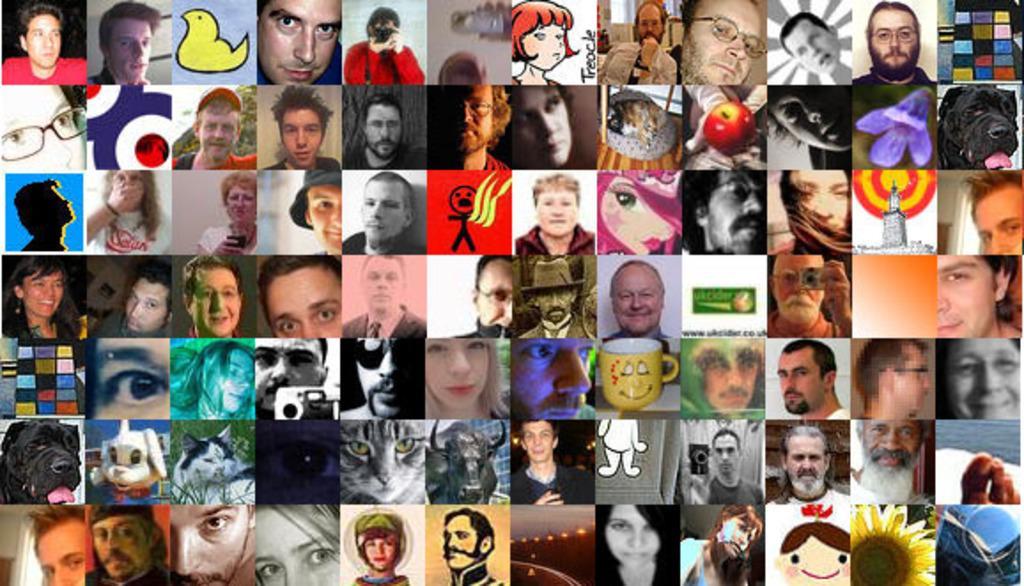Can you describe this image briefly? In the picture I can see the collage images. I can see the face of persons, images of animals, flowers and a cup in the college images. 